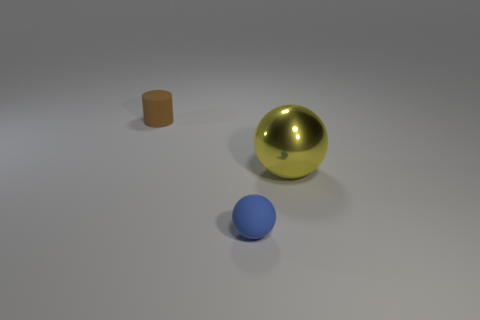Add 1 big purple matte cubes. How many objects exist? 4 Add 1 big yellow things. How many big yellow things are left? 2 Add 3 large shiny balls. How many large shiny balls exist? 4 Subtract 0 green spheres. How many objects are left? 3 Subtract all spheres. How many objects are left? 1 Subtract 2 balls. How many balls are left? 0 Subtract all yellow balls. Subtract all blue cubes. How many balls are left? 1 Subtract all brown cylinders. How many yellow balls are left? 1 Subtract all small blue balls. Subtract all tiny brown metallic cylinders. How many objects are left? 2 